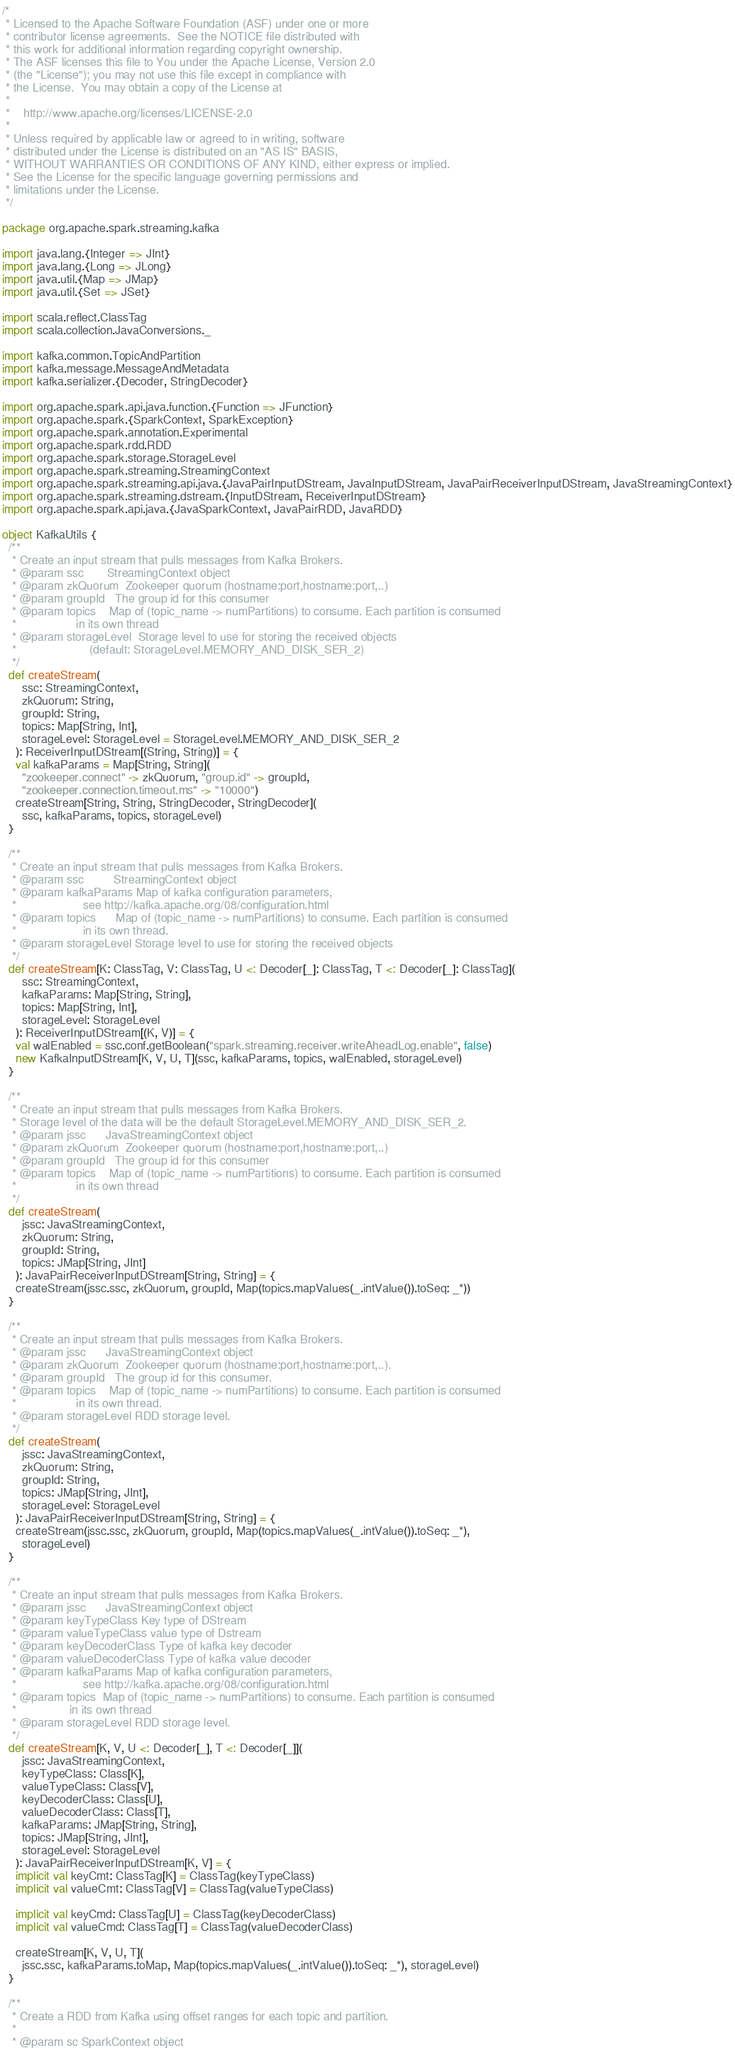<code> <loc_0><loc_0><loc_500><loc_500><_Scala_>/*
 * Licensed to the Apache Software Foundation (ASF) under one or more
 * contributor license agreements.  See the NOTICE file distributed with
 * this work for additional information regarding copyright ownership.
 * The ASF licenses this file to You under the Apache License, Version 2.0
 * (the "License"); you may not use this file except in compliance with
 * the License.  You may obtain a copy of the License at
 *
 *    http://www.apache.org/licenses/LICENSE-2.0
 *
 * Unless required by applicable law or agreed to in writing, software
 * distributed under the License is distributed on an "AS IS" BASIS,
 * WITHOUT WARRANTIES OR CONDITIONS OF ANY KIND, either express or implied.
 * See the License for the specific language governing permissions and
 * limitations under the License.
 */

package org.apache.spark.streaming.kafka

import java.lang.{Integer => JInt}
import java.lang.{Long => JLong}
import java.util.{Map => JMap}
import java.util.{Set => JSet}

import scala.reflect.ClassTag
import scala.collection.JavaConversions._

import kafka.common.TopicAndPartition
import kafka.message.MessageAndMetadata
import kafka.serializer.{Decoder, StringDecoder}

import org.apache.spark.api.java.function.{Function => JFunction}
import org.apache.spark.{SparkContext, SparkException}
import org.apache.spark.annotation.Experimental
import org.apache.spark.rdd.RDD
import org.apache.spark.storage.StorageLevel
import org.apache.spark.streaming.StreamingContext
import org.apache.spark.streaming.api.java.{JavaPairInputDStream, JavaInputDStream, JavaPairReceiverInputDStream, JavaStreamingContext}
import org.apache.spark.streaming.dstream.{InputDStream, ReceiverInputDStream}
import org.apache.spark.api.java.{JavaSparkContext, JavaPairRDD, JavaRDD}

object KafkaUtils {
  /**
   * Create an input stream that pulls messages from Kafka Brokers.
   * @param ssc       StreamingContext object
   * @param zkQuorum  Zookeeper quorum (hostname:port,hostname:port,..)
   * @param groupId   The group id for this consumer
   * @param topics    Map of (topic_name -> numPartitions) to consume. Each partition is consumed
   *                  in its own thread
   * @param storageLevel  Storage level to use for storing the received objects
   *                      (default: StorageLevel.MEMORY_AND_DISK_SER_2)
   */
  def createStream(
      ssc: StreamingContext,
      zkQuorum: String,
      groupId: String,
      topics: Map[String, Int],
      storageLevel: StorageLevel = StorageLevel.MEMORY_AND_DISK_SER_2
    ): ReceiverInputDStream[(String, String)] = {
    val kafkaParams = Map[String, String](
      "zookeeper.connect" -> zkQuorum, "group.id" -> groupId,
      "zookeeper.connection.timeout.ms" -> "10000")
    createStream[String, String, StringDecoder, StringDecoder](
      ssc, kafkaParams, topics, storageLevel)
  }

  /**
   * Create an input stream that pulls messages from Kafka Brokers.
   * @param ssc         StreamingContext object
   * @param kafkaParams Map of kafka configuration parameters,
   *                    see http://kafka.apache.org/08/configuration.html
   * @param topics      Map of (topic_name -> numPartitions) to consume. Each partition is consumed
   *                    in its own thread.
   * @param storageLevel Storage level to use for storing the received objects
   */
  def createStream[K: ClassTag, V: ClassTag, U <: Decoder[_]: ClassTag, T <: Decoder[_]: ClassTag](
      ssc: StreamingContext,
      kafkaParams: Map[String, String],
      topics: Map[String, Int],
      storageLevel: StorageLevel
    ): ReceiverInputDStream[(K, V)] = {
    val walEnabled = ssc.conf.getBoolean("spark.streaming.receiver.writeAheadLog.enable", false)
    new KafkaInputDStream[K, V, U, T](ssc, kafkaParams, topics, walEnabled, storageLevel)
  }

  /**
   * Create an input stream that pulls messages from Kafka Brokers.
   * Storage level of the data will be the default StorageLevel.MEMORY_AND_DISK_SER_2.
   * @param jssc      JavaStreamingContext object
   * @param zkQuorum  Zookeeper quorum (hostname:port,hostname:port,..)
   * @param groupId   The group id for this consumer
   * @param topics    Map of (topic_name -> numPartitions) to consume. Each partition is consumed
   *                  in its own thread
   */
  def createStream(
      jssc: JavaStreamingContext,
      zkQuorum: String,
      groupId: String,
      topics: JMap[String, JInt]
    ): JavaPairReceiverInputDStream[String, String] = {
    createStream(jssc.ssc, zkQuorum, groupId, Map(topics.mapValues(_.intValue()).toSeq: _*))
  }

  /**
   * Create an input stream that pulls messages from Kafka Brokers.
   * @param jssc      JavaStreamingContext object
   * @param zkQuorum  Zookeeper quorum (hostname:port,hostname:port,..).
   * @param groupId   The group id for this consumer.
   * @param topics    Map of (topic_name -> numPartitions) to consume. Each partition is consumed
   *                  in its own thread.
   * @param storageLevel RDD storage level.
   */
  def createStream(
      jssc: JavaStreamingContext,
      zkQuorum: String,
      groupId: String,
      topics: JMap[String, JInt],
      storageLevel: StorageLevel
    ): JavaPairReceiverInputDStream[String, String] = {
    createStream(jssc.ssc, zkQuorum, groupId, Map(topics.mapValues(_.intValue()).toSeq: _*),
      storageLevel)
  }

  /**
   * Create an input stream that pulls messages from Kafka Brokers.
   * @param jssc      JavaStreamingContext object
   * @param keyTypeClass Key type of DStream
   * @param valueTypeClass value type of Dstream
   * @param keyDecoderClass Type of kafka key decoder
   * @param valueDecoderClass Type of kafka value decoder
   * @param kafkaParams Map of kafka configuration parameters,
   *                    see http://kafka.apache.org/08/configuration.html
   * @param topics  Map of (topic_name -> numPartitions) to consume. Each partition is consumed
   *                in its own thread
   * @param storageLevel RDD storage level.
   */
  def createStream[K, V, U <: Decoder[_], T <: Decoder[_]](
      jssc: JavaStreamingContext,
      keyTypeClass: Class[K],
      valueTypeClass: Class[V],
      keyDecoderClass: Class[U],
      valueDecoderClass: Class[T],
      kafkaParams: JMap[String, String],
      topics: JMap[String, JInt],
      storageLevel: StorageLevel
    ): JavaPairReceiverInputDStream[K, V] = {
    implicit val keyCmt: ClassTag[K] = ClassTag(keyTypeClass)
    implicit val valueCmt: ClassTag[V] = ClassTag(valueTypeClass)

    implicit val keyCmd: ClassTag[U] = ClassTag(keyDecoderClass)
    implicit val valueCmd: ClassTag[T] = ClassTag(valueDecoderClass)

    createStream[K, V, U, T](
      jssc.ssc, kafkaParams.toMap, Map(topics.mapValues(_.intValue()).toSeq: _*), storageLevel)
  }

  /**
   * Create a RDD from Kafka using offset ranges for each topic and partition.
   *
   * @param sc SparkContext object</code> 